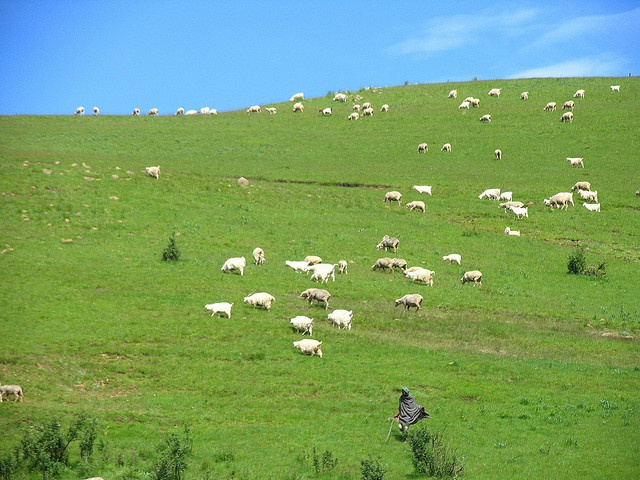Describe the objects in this image and their specific colors. I can see sheep in gray, olive, ivory, and beige tones, people in gray, black, darkgray, and olive tones, sheep in gray, beige, darkgreen, and olive tones, sheep in gray, ivory, olive, and beige tones, and sheep in gray, beige, khaki, olive, and darkgreen tones in this image. 